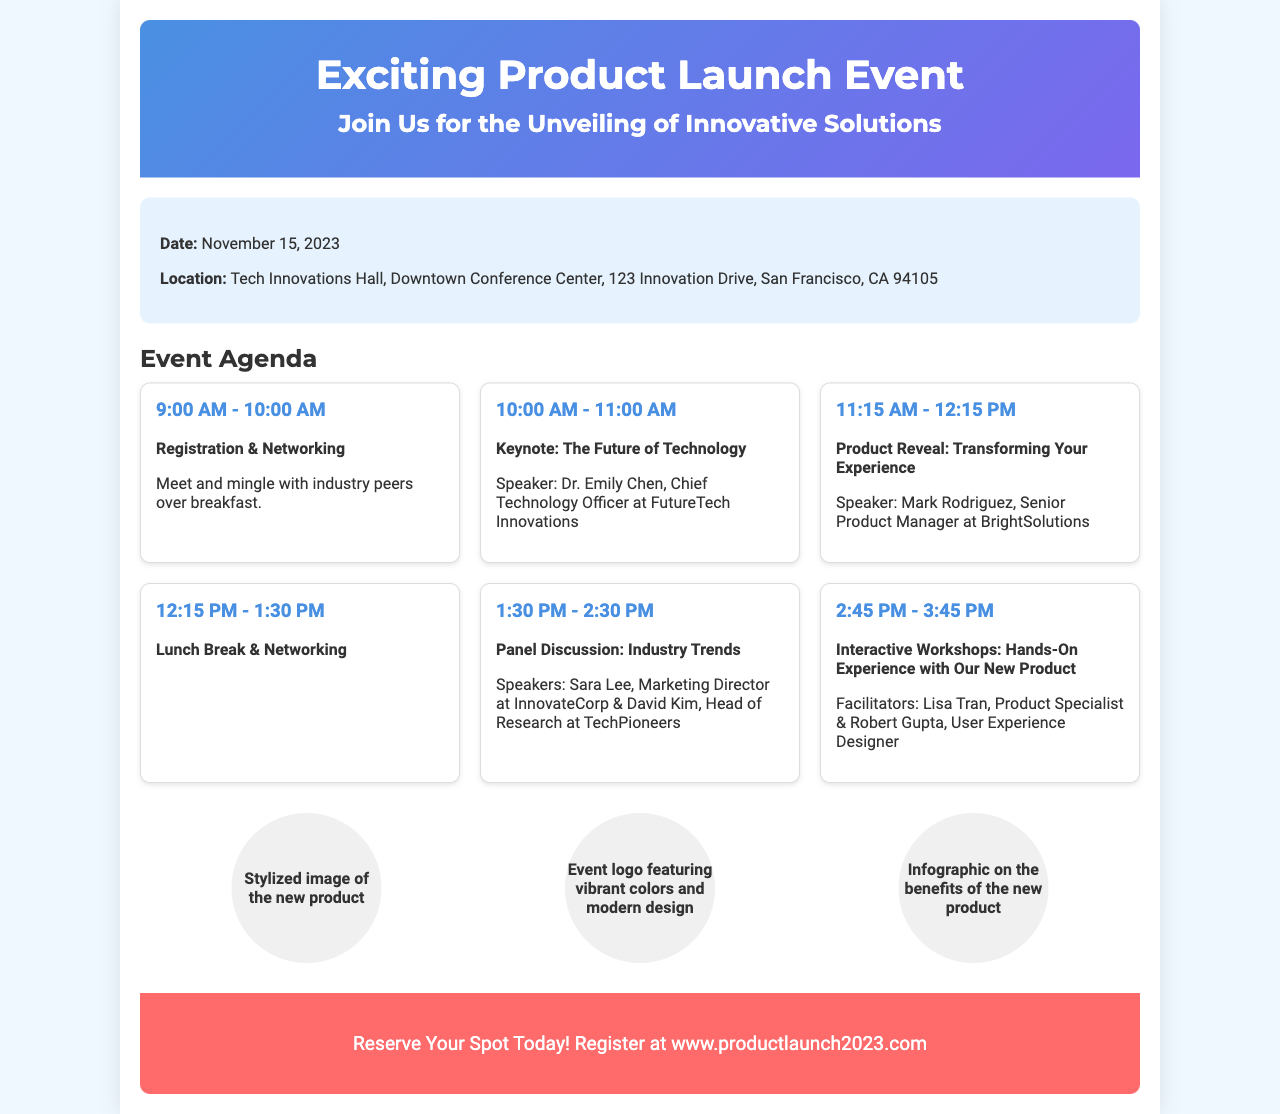What is the date of the event? The date of the event is explicitly mentioned in the document as November 15, 2023.
Answer: November 15, 2023 Where is the event taking place? The document specifies the location as "Tech Innovations Hall, Downtown Conference Center, 123 Innovation Drive, San Francisco, CA 94105."
Answer: Tech Innovations Hall, Downtown Conference Center, 123 Innovation Drive, San Francisco, CA 94105 Who is the keynote speaker? The document states that Dr. Emily Chen is the keynote speaker and provides her title, which is Chief Technology Officer at FutureTech Innovations.
Answer: Dr. Emily Chen What time does registration start? According to the event agenda, registration begins at 9:00 AM.
Answer: 9:00 AM How long is the lunch break? The agenda details the lunch break duration as 1 hour and 15 minutes, from 12:15 PM to 1:30 PM.
Answer: 1 hour and 15 minutes What is the main focus of the event? The focus of the event is highlighted in the title, emphasizing the unveiling of innovative solutions.
Answer: Unveiling of innovative solutions What type of activity follows the keynote speech? The document describes a product reveal that occurs after the keynote speech.
Answer: Product Reveal What do attendees need to do to reserve a spot? The call to action specifies that attendees should register at the provided website.
Answer: Register at www.productlaunch2023.com 